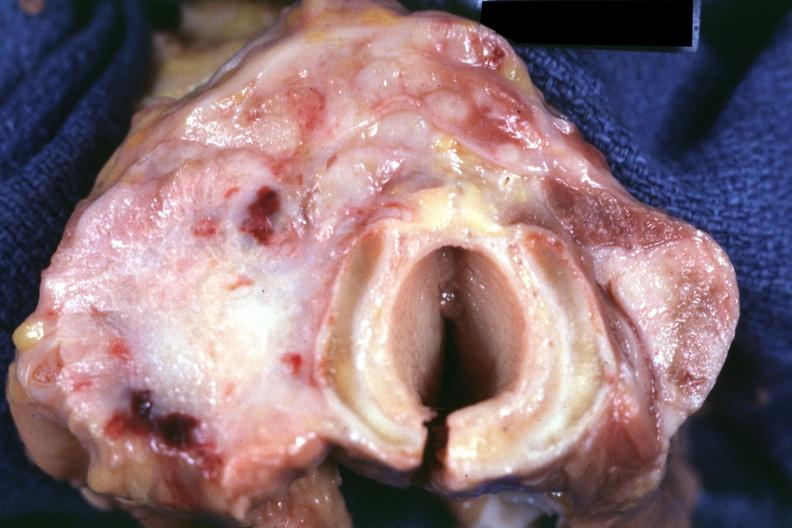does this image show section through thyroid and trachea apparently?
Answer the question using a single word or phrase. Yes 